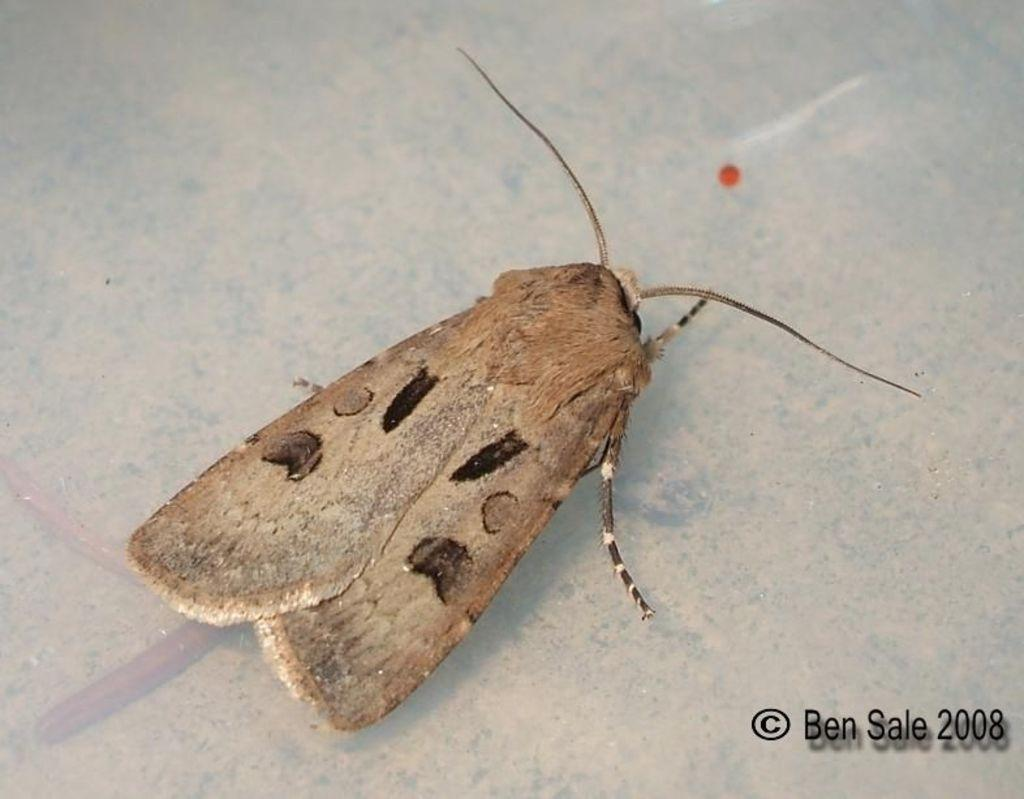What type of creature is present in the image? There is an insect in the image. Where is the insect located in the image? The insect is on a surface. How many babies are crawling on the car in the image? There is no car or babies present in the image; it only features an insect on a surface. Can you describe the snake that is coiled around the insect in the image? There is no snake present in the image; it only features an insect on a surface. 